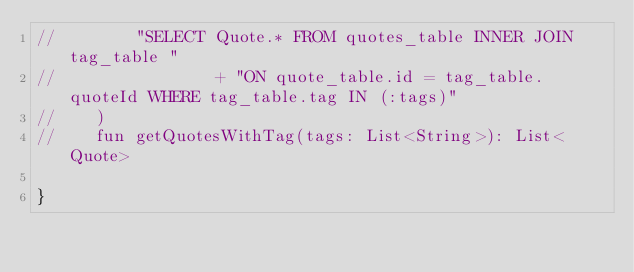<code> <loc_0><loc_0><loc_500><loc_500><_Kotlin_>//        "SELECT Quote.* FROM quotes_table INNER JOIN tag_table "
//                + "ON quote_table.id = tag_table.quoteId WHERE tag_table.tag IN (:tags)"
//    )
//    fun getQuotesWithTag(tags: List<String>): List<Quote>

}</code> 